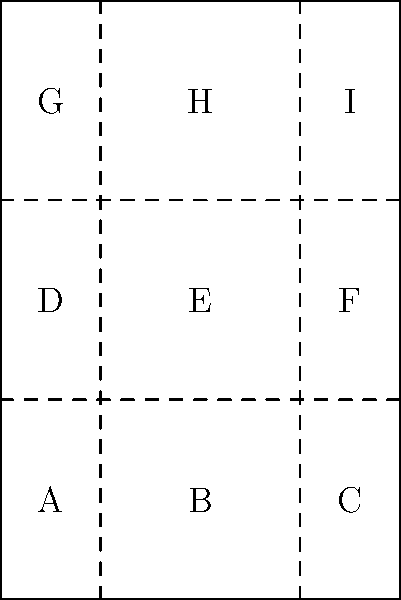Imagine folding a movie poster of Gale Anne Hurd's latest production into an origami shape for The Geekie Awards. If you fold the poster along the dashed lines, which sections will come into contact with each other when the poster is completely folded? To determine which sections will come into contact when the poster is completely folded, let's follow these steps:

1. The poster is divided into 9 sections (A through I) by the dashed fold lines.

2. Vertical folds:
   - Folding along the left vertical line brings A, D, and G over B, E, and H.
   - Folding along the right vertical line brings C, F, and I over B, E, and H.

3. Horizontal folds:
   - Folding along the bottom horizontal line brings D, E, and F over A, B, and C.
   - Folding along the top horizontal line brings G, H, and I over D, E, and F.

4. When all folds are complete:
   - A will be in contact with I
   - B will be in contact with H
   - C will be in contact with G
   - D will be in contact with F
   - E will be in the center, potentially touching all other sections

5. The final configuration will have E in the center, surrounded by the other sections in a layered manner.
Answer: A-I, B-H, C-G, D-F, E-all 